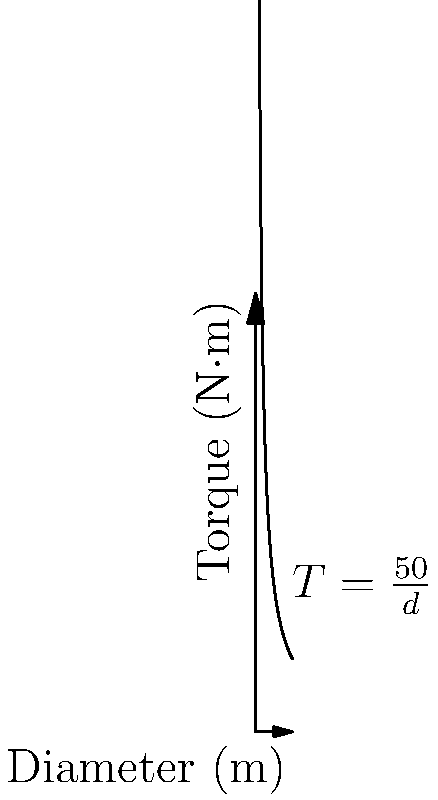A local business wants to install a rotating cylindrical digital display sign. The torque ($T$) required to rotate the sign is inversely proportional to its diameter ($d$), following the equation $T = \frac{50}{d}$, where $T$ is in N·m and $d$ is in meters. If the business wants to limit the torque to 25 N·m, what should be the minimum diameter of the sign? To solve this problem, we'll follow these steps:

1. We're given the equation: $T = \frac{50}{d}$
   Where $T$ is torque in N·m and $d$ is diameter in meters.

2. We want to find $d$ when $T = 25$ N·m.

3. Substitute the known values into the equation:
   $25 = \frac{50}{d}$

4. Multiply both sides by $d$:
   $25d = 50$

5. Divide both sides by 25:
   $d = \frac{50}{25} = 2$

Therefore, the minimum diameter of the sign should be 2 meters to limit the torque to 25 N·m.
Answer: 2 meters 